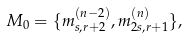Convert formula to latex. <formula><loc_0><loc_0><loc_500><loc_500>M _ { 0 } = \{ m _ { s , r + 2 } ^ { ( n - 2 ) } , m _ { 2 s , r + 1 } ^ { ( n ) } \} ,</formula> 